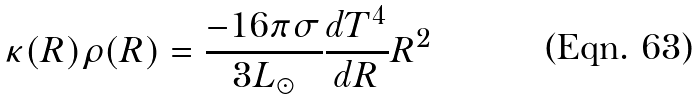Convert formula to latex. <formula><loc_0><loc_0><loc_500><loc_500>\kappa ( R ) \rho ( R ) = \frac { - 1 6 \pi \sigma } { 3 L _ { \odot } } \frac { d T ^ { 4 } } { d R } R ^ { 2 }</formula> 